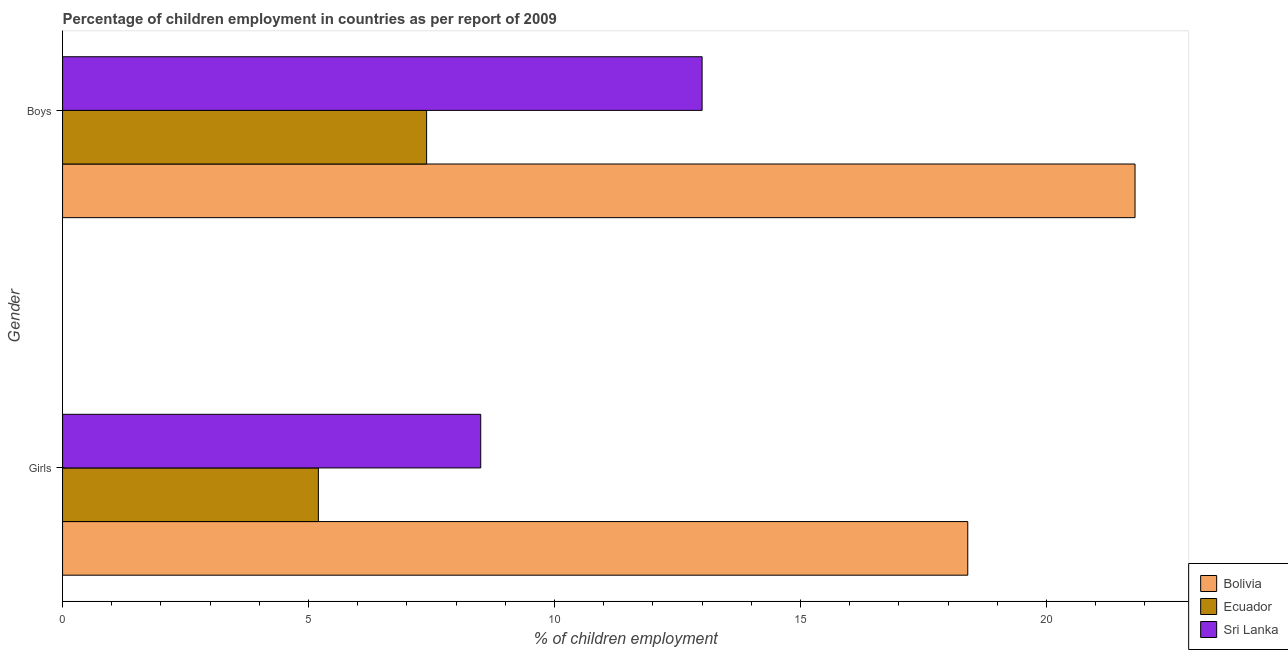Are the number of bars per tick equal to the number of legend labels?
Your answer should be very brief. Yes. How many bars are there on the 2nd tick from the top?
Offer a very short reply. 3. How many bars are there on the 1st tick from the bottom?
Ensure brevity in your answer.  3. What is the label of the 1st group of bars from the top?
Keep it short and to the point. Boys. Across all countries, what is the maximum percentage of employed boys?
Ensure brevity in your answer.  21.8. In which country was the percentage of employed boys minimum?
Keep it short and to the point. Ecuador. What is the total percentage of employed girls in the graph?
Keep it short and to the point. 32.1. What is the difference between the percentage of employed boys in Ecuador and that in Sri Lanka?
Provide a short and direct response. -5.6. What is the difference between the percentage of employed girls in Bolivia and the percentage of employed boys in Sri Lanka?
Your answer should be compact. 5.4. What is the average percentage of employed girls per country?
Provide a short and direct response. 10.7. What is the difference between the percentage of employed boys and percentage of employed girls in Bolivia?
Provide a succinct answer. 3.4. In how many countries, is the percentage of employed girls greater than 9 %?
Offer a very short reply. 1. What is the ratio of the percentage of employed girls in Sri Lanka to that in Ecuador?
Your answer should be very brief. 1.63. Is the percentage of employed girls in Ecuador less than that in Bolivia?
Provide a succinct answer. Yes. In how many countries, is the percentage of employed boys greater than the average percentage of employed boys taken over all countries?
Give a very brief answer. 1. What does the 2nd bar from the top in Boys represents?
Provide a short and direct response. Ecuador. What does the 3rd bar from the bottom in Girls represents?
Give a very brief answer. Sri Lanka. Are all the bars in the graph horizontal?
Provide a succinct answer. Yes. Does the graph contain grids?
Provide a short and direct response. No. Where does the legend appear in the graph?
Provide a succinct answer. Bottom right. What is the title of the graph?
Provide a succinct answer. Percentage of children employment in countries as per report of 2009. Does "St. Lucia" appear as one of the legend labels in the graph?
Your response must be concise. No. What is the label or title of the X-axis?
Your response must be concise. % of children employment. What is the % of children employment of Ecuador in Girls?
Give a very brief answer. 5.2. What is the % of children employment of Sri Lanka in Girls?
Offer a very short reply. 8.5. What is the % of children employment in Bolivia in Boys?
Your answer should be very brief. 21.8. What is the % of children employment of Ecuador in Boys?
Your answer should be compact. 7.4. Across all Gender, what is the maximum % of children employment of Bolivia?
Offer a terse response. 21.8. Across all Gender, what is the maximum % of children employment of Ecuador?
Your answer should be compact. 7.4. Across all Gender, what is the maximum % of children employment of Sri Lanka?
Your answer should be very brief. 13. Across all Gender, what is the minimum % of children employment of Bolivia?
Your response must be concise. 18.4. Across all Gender, what is the minimum % of children employment in Ecuador?
Make the answer very short. 5.2. Across all Gender, what is the minimum % of children employment in Sri Lanka?
Your answer should be very brief. 8.5. What is the total % of children employment in Bolivia in the graph?
Provide a short and direct response. 40.2. What is the total % of children employment in Ecuador in the graph?
Keep it short and to the point. 12.6. What is the difference between the % of children employment of Ecuador in Girls and that in Boys?
Offer a terse response. -2.2. What is the difference between the % of children employment of Sri Lanka in Girls and that in Boys?
Provide a succinct answer. -4.5. What is the difference between the % of children employment in Ecuador in Girls and the % of children employment in Sri Lanka in Boys?
Offer a terse response. -7.8. What is the average % of children employment in Bolivia per Gender?
Your response must be concise. 20.1. What is the average % of children employment of Sri Lanka per Gender?
Give a very brief answer. 10.75. What is the difference between the % of children employment of Bolivia and % of children employment of Ecuador in Girls?
Your response must be concise. 13.2. What is the difference between the % of children employment of Bolivia and % of children employment of Sri Lanka in Girls?
Provide a succinct answer. 9.9. What is the difference between the % of children employment of Bolivia and % of children employment of Sri Lanka in Boys?
Ensure brevity in your answer.  8.8. What is the ratio of the % of children employment in Bolivia in Girls to that in Boys?
Provide a succinct answer. 0.84. What is the ratio of the % of children employment in Ecuador in Girls to that in Boys?
Offer a terse response. 0.7. What is the ratio of the % of children employment of Sri Lanka in Girls to that in Boys?
Your answer should be very brief. 0.65. What is the difference between the highest and the second highest % of children employment of Sri Lanka?
Provide a short and direct response. 4.5. What is the difference between the highest and the lowest % of children employment of Ecuador?
Offer a terse response. 2.2. What is the difference between the highest and the lowest % of children employment of Sri Lanka?
Provide a succinct answer. 4.5. 